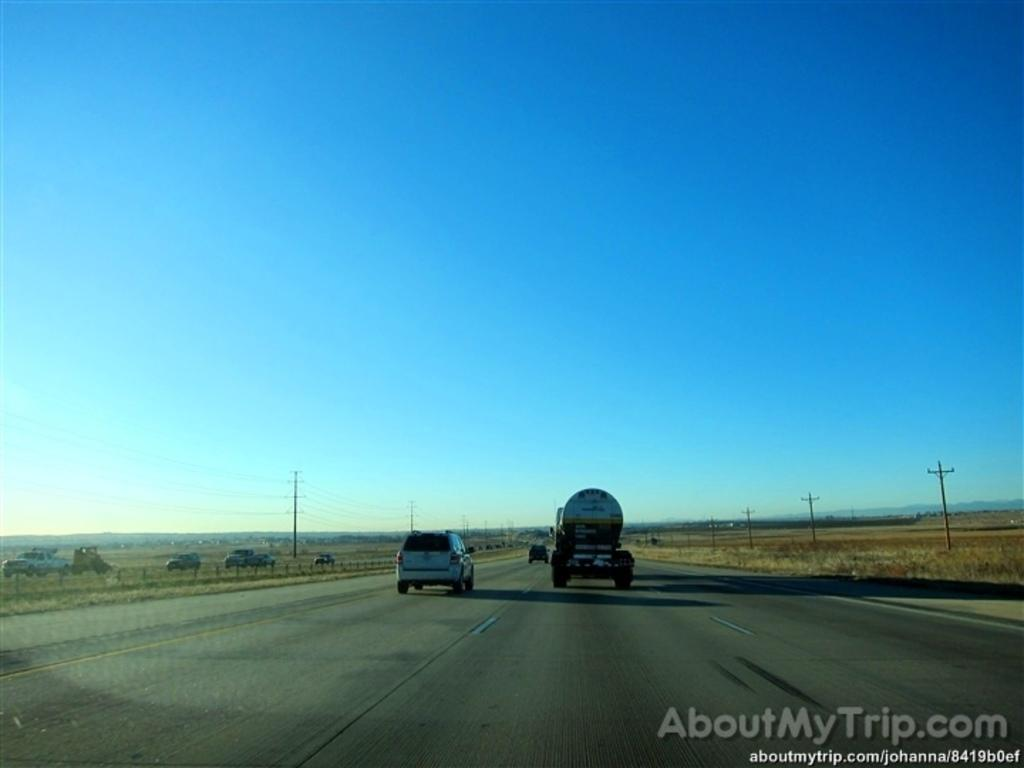What is happening on the road in the image? There are vehicles moving on the road in the image. What can be seen in the image besides the vehicles? There are poles and grass visible in the image. Where is the text located in the image? The text is visible at the bottom right of the image. How are the vehicles being sorted in the image? There is no indication in the image that the vehicles are being sorted; they are simply moving on the road. What type of yoke is being used by the cows in the image? There are no cows or yokes present in the image. 